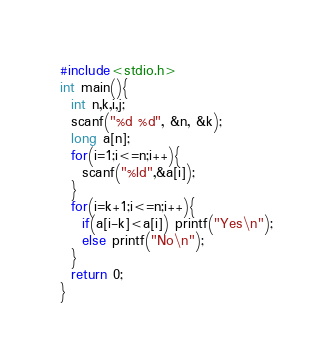Convert code to text. <code><loc_0><loc_0><loc_500><loc_500><_C_>#include<stdio.h>
int main(){
  int n,k,i,j;
  scanf("%d %d", &n, &k);
  long a[n];
  for(i=1;i<=n;i++){
    scanf("%ld",&a[i]);
  }
  for(i=k+1;i<=n;i++){
    if(a[i-k]<a[i]) printf("Yes\n");
    else printf("No\n");
  }
  return 0;
}
</code> 